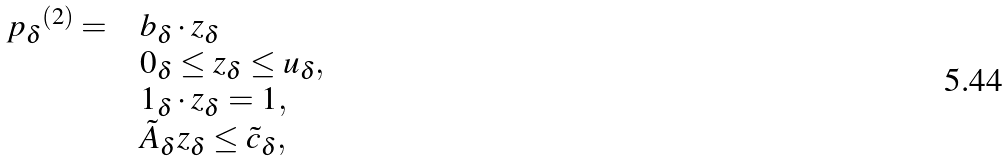Convert formula to latex. <formula><loc_0><loc_0><loc_500><loc_500>\begin{array} { r l l r } { p _ { \delta } } ^ { ( 2 ) } = & & b _ { \delta } \cdot z _ { \delta } \\ & & 0 _ { \delta } \leq z _ { \delta } \leq u _ { \delta } , \\ & & 1 _ { \delta } \cdot z _ { \delta } = 1 , \\ & & \tilde { A } _ { \delta } z _ { \delta } \leq \tilde { c } _ { \delta } , \end{array}</formula> 